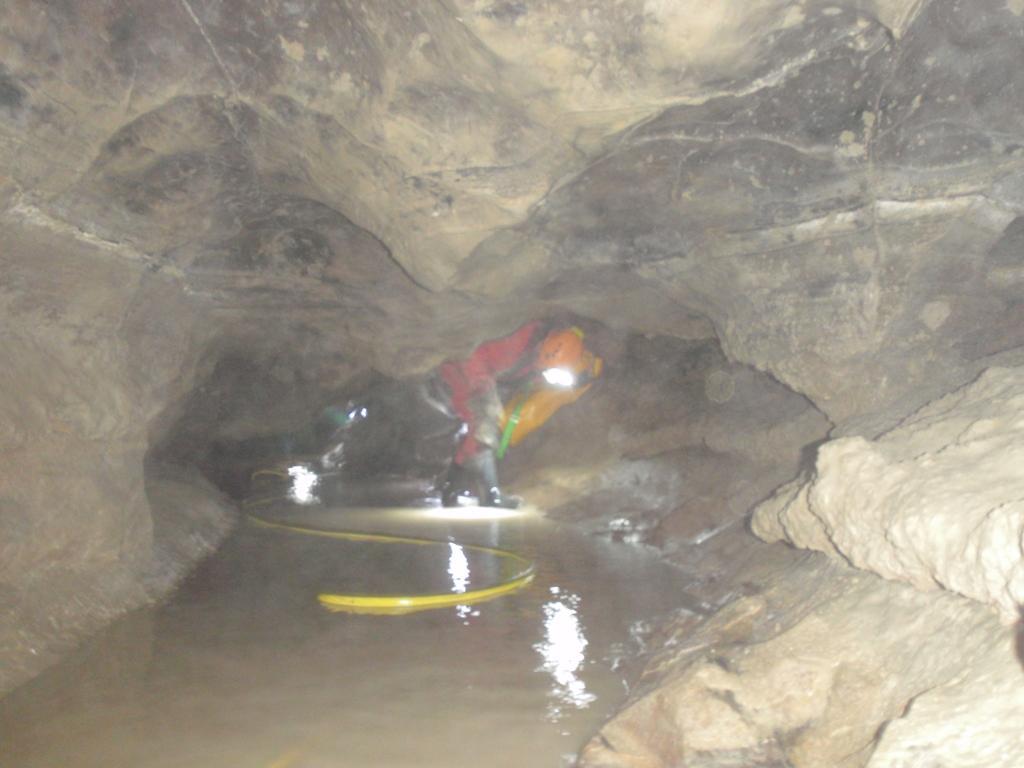Please provide a concise description of this image. This is an underground image, in this image at the top there are rocks and in the center there are some people who are wearing helmets and there is a pipe and some water. 